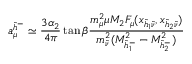Convert formula to latex. <formula><loc_0><loc_0><loc_500><loc_500>a _ { \mu } ^ { \tilde { h } ^ { - } } \simeq { \frac { 3 \alpha _ { 2 } } { 4 \pi } } \tan \beta { \frac { m _ { \mu } ^ { 2 } \mu M _ { 2 } F _ { \mu } ( x _ { \tilde { h } _ { 1 } \tilde { \nu } } , x _ { \tilde { h } _ { 2 } \tilde { \nu } } ) } { m _ { \tilde { \nu } } ^ { 2 } ( M _ { \tilde { h } _ { 1 } ^ { - } } ^ { 2 } - M _ { \tilde { h } _ { 2 } ^ { - } } ^ { 2 } ) } }</formula> 